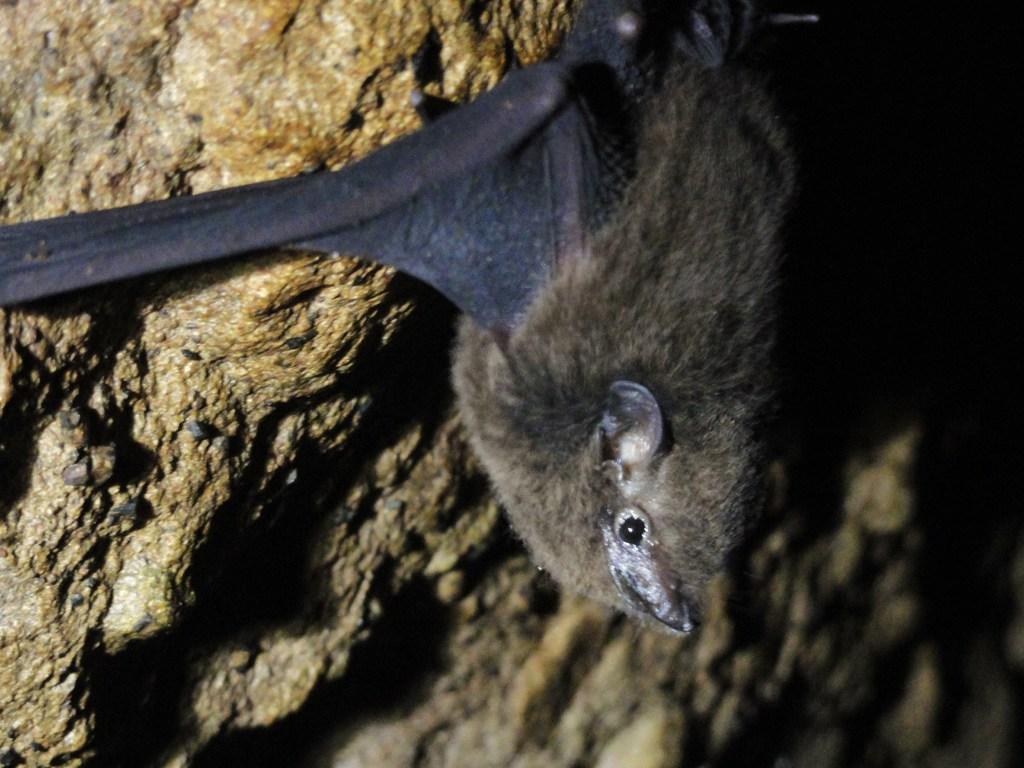Describe this image in one or two sentences. In the image there is a bat hanging to a stone wall. 